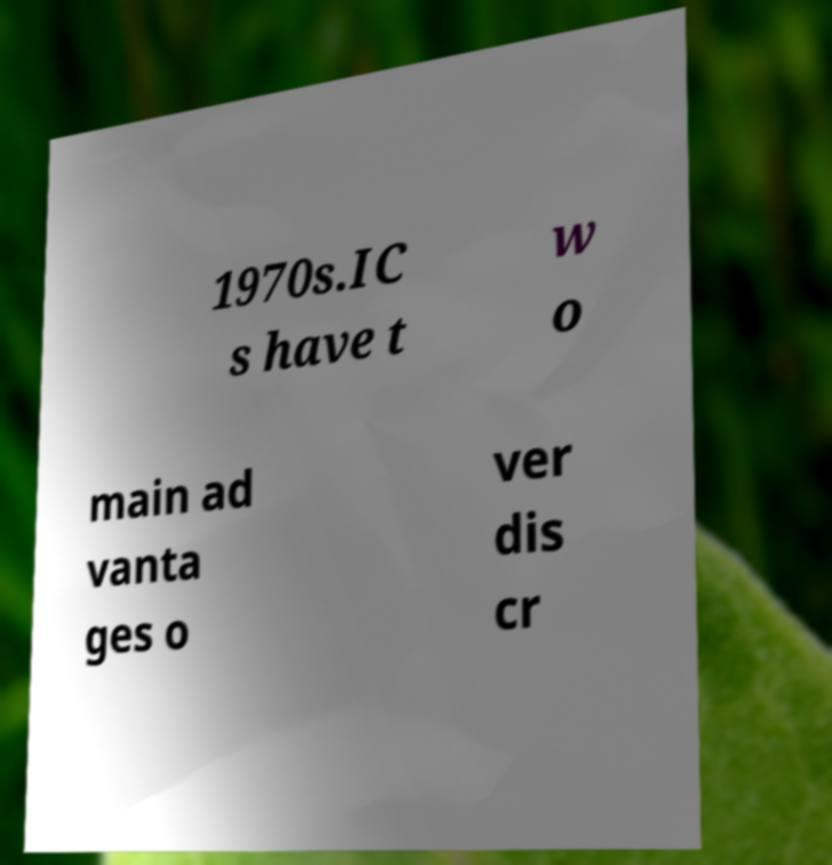What messages or text are displayed in this image? I need them in a readable, typed format. 1970s.IC s have t w o main ad vanta ges o ver dis cr 